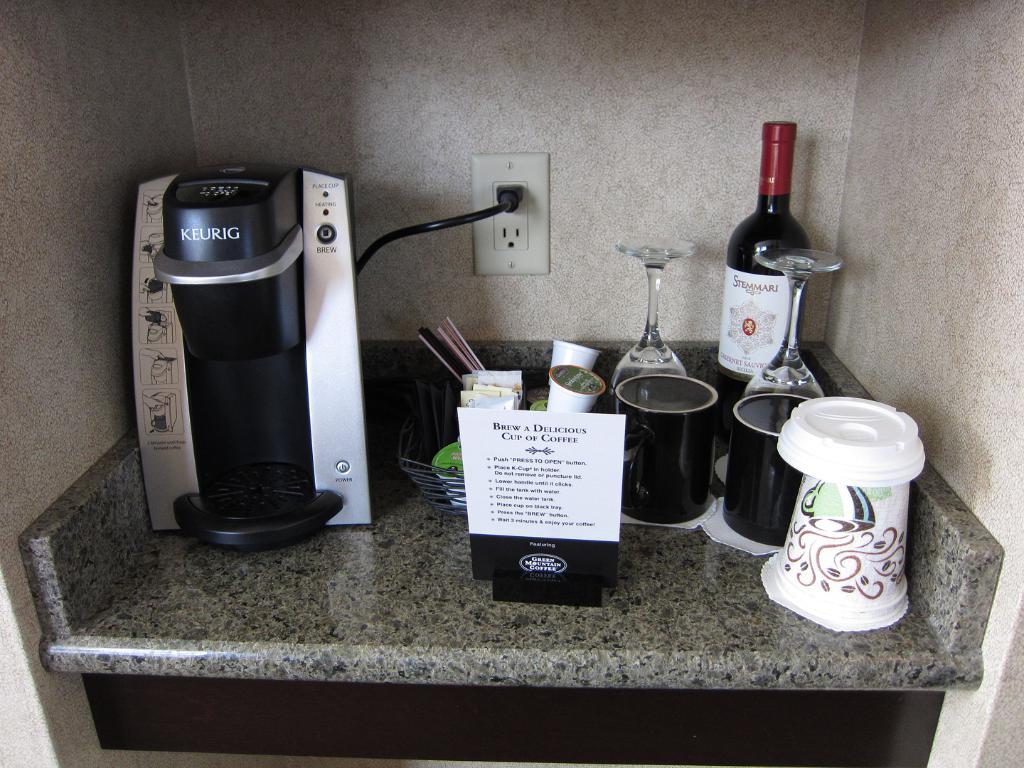What is the brand of the appliance?
Offer a very short reply. Keurig. What is the first instruction to brew a delicious cup of coffee?
Your answer should be very brief. Unanswerable. 